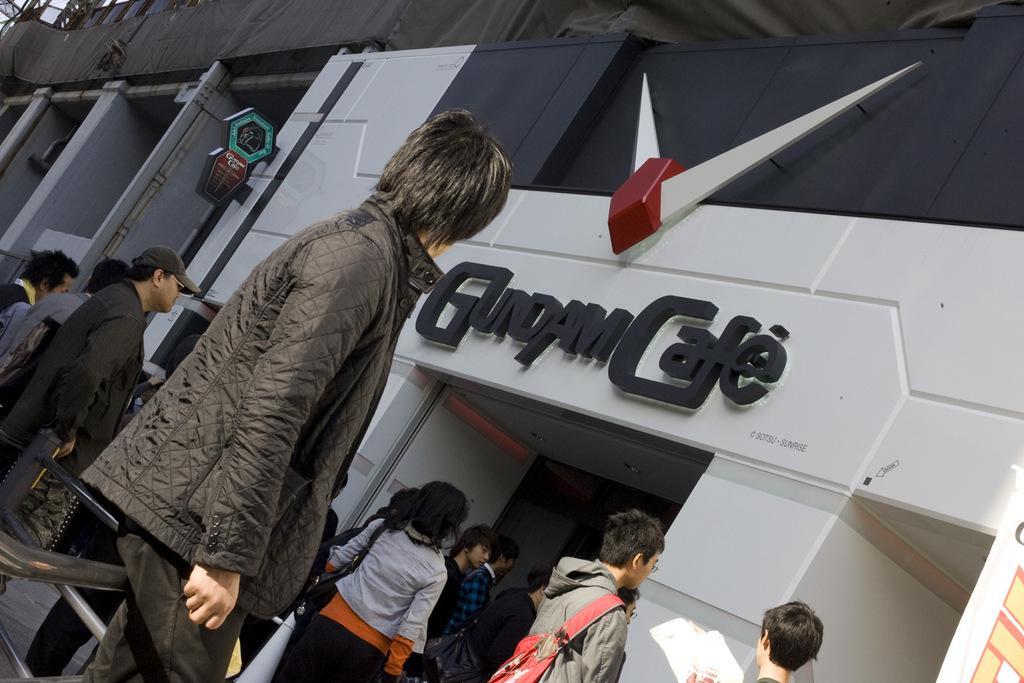How would you summarize this image in a sentence or two? In this image I can see people. Here I can see buildings on which I can see some name and objects attached to it. 